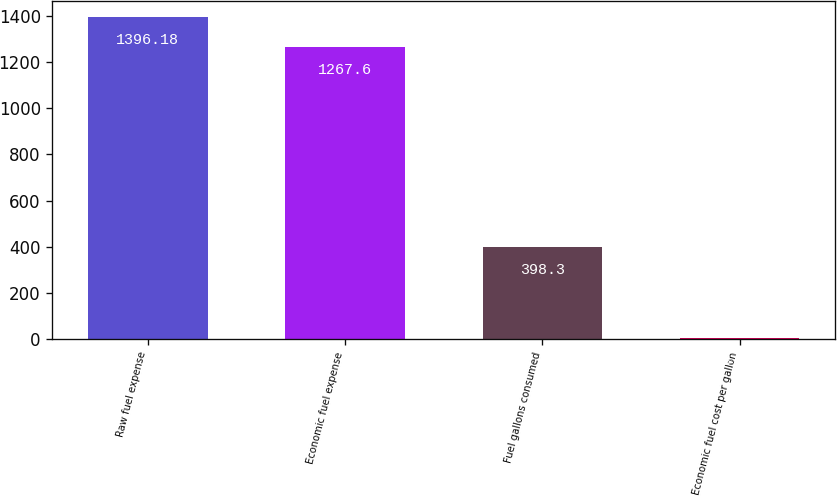<chart> <loc_0><loc_0><loc_500><loc_500><bar_chart><fcel>Raw fuel expense<fcel>Economic fuel expense<fcel>Fuel gallons consumed<fcel>Economic fuel cost per gallon<nl><fcel>1396.18<fcel>1267.6<fcel>398.3<fcel>3.18<nl></chart> 